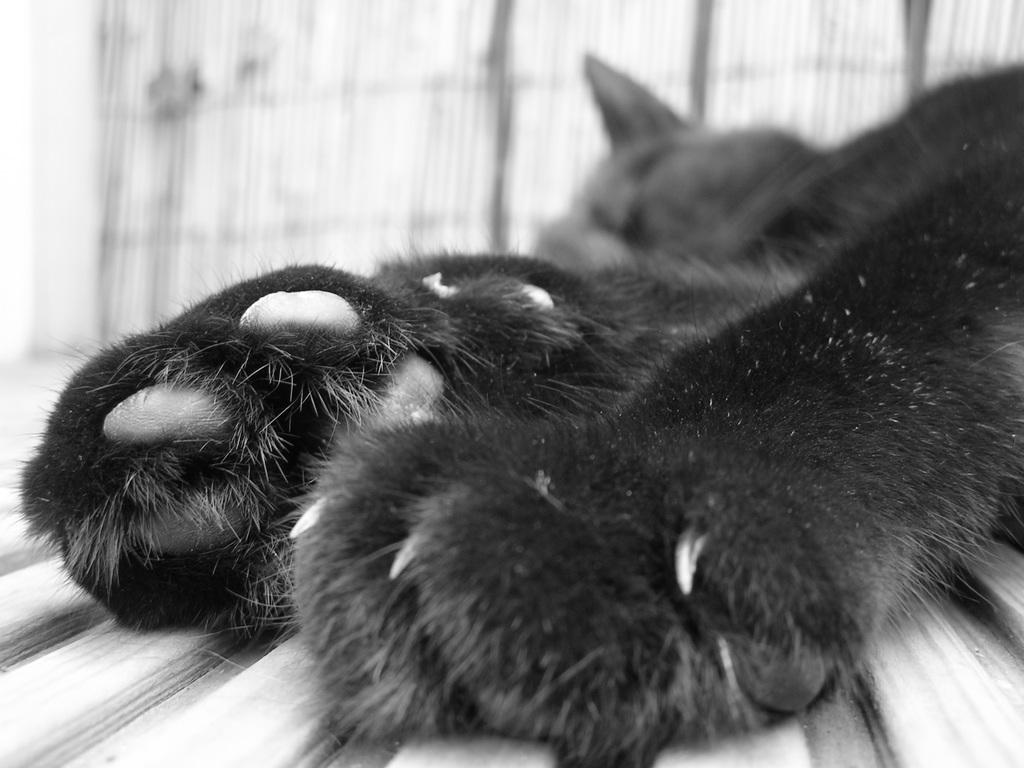What type of animal can be seen in the image? There is an animal in the image, but its specific type cannot be determined from the provided facts. What position is the animal in? The animal is lying on the floor in the image. What can be seen in the background of the image? There is a curtain in the background of the image. What type of drink is the animal holding in the image? There is no drink present in the image, as the animal is lying on the floor and not holding anything. 